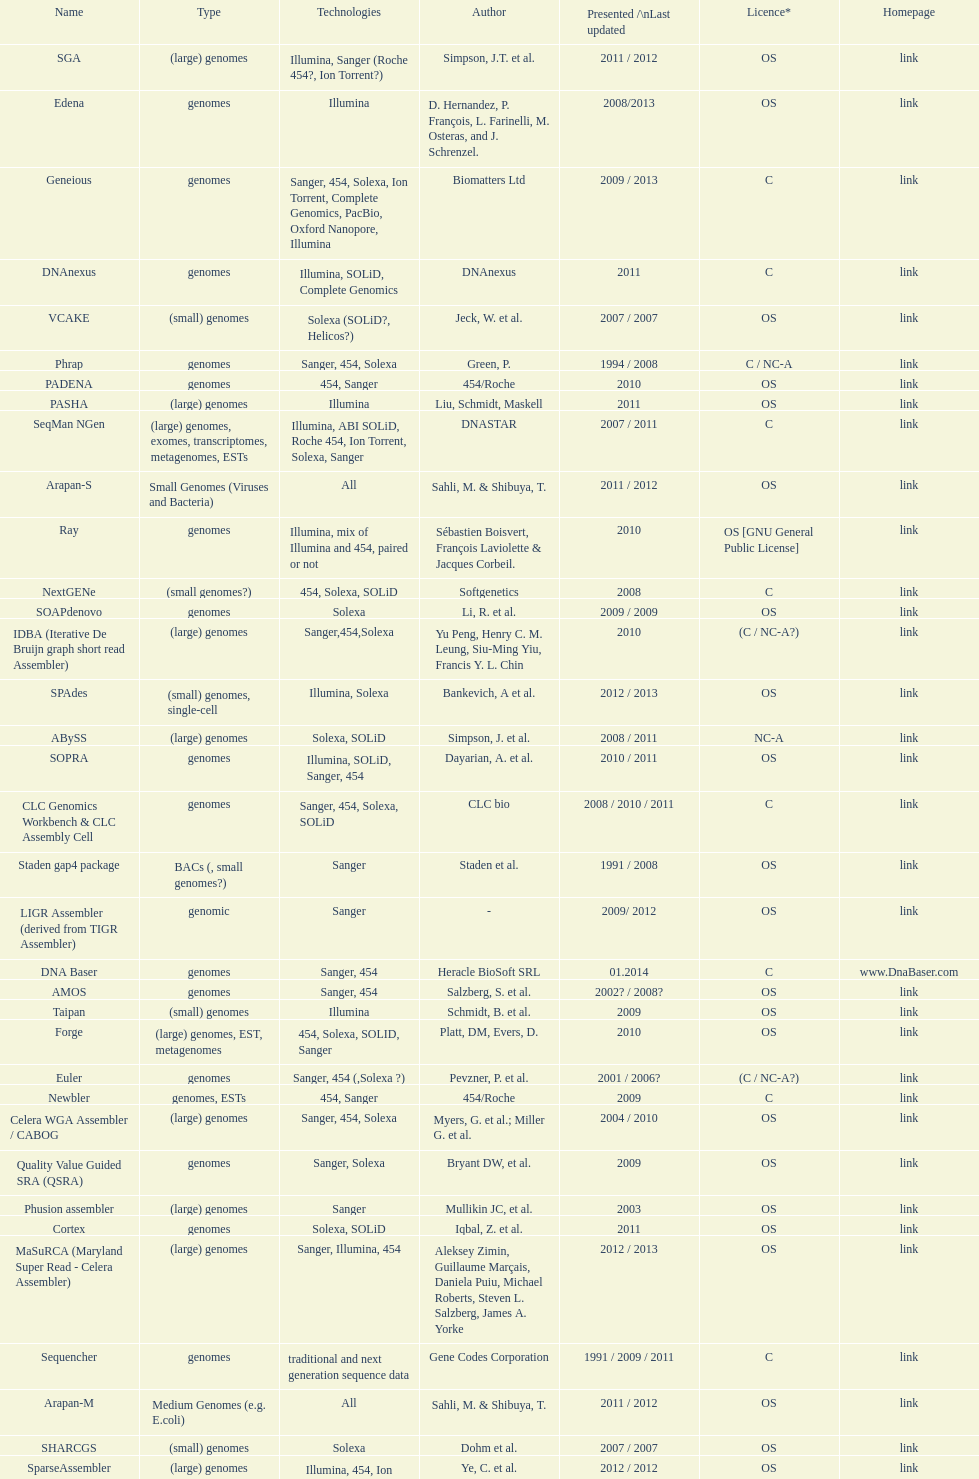What is the total number of assemblers supporting small genomes type technologies? 9. 